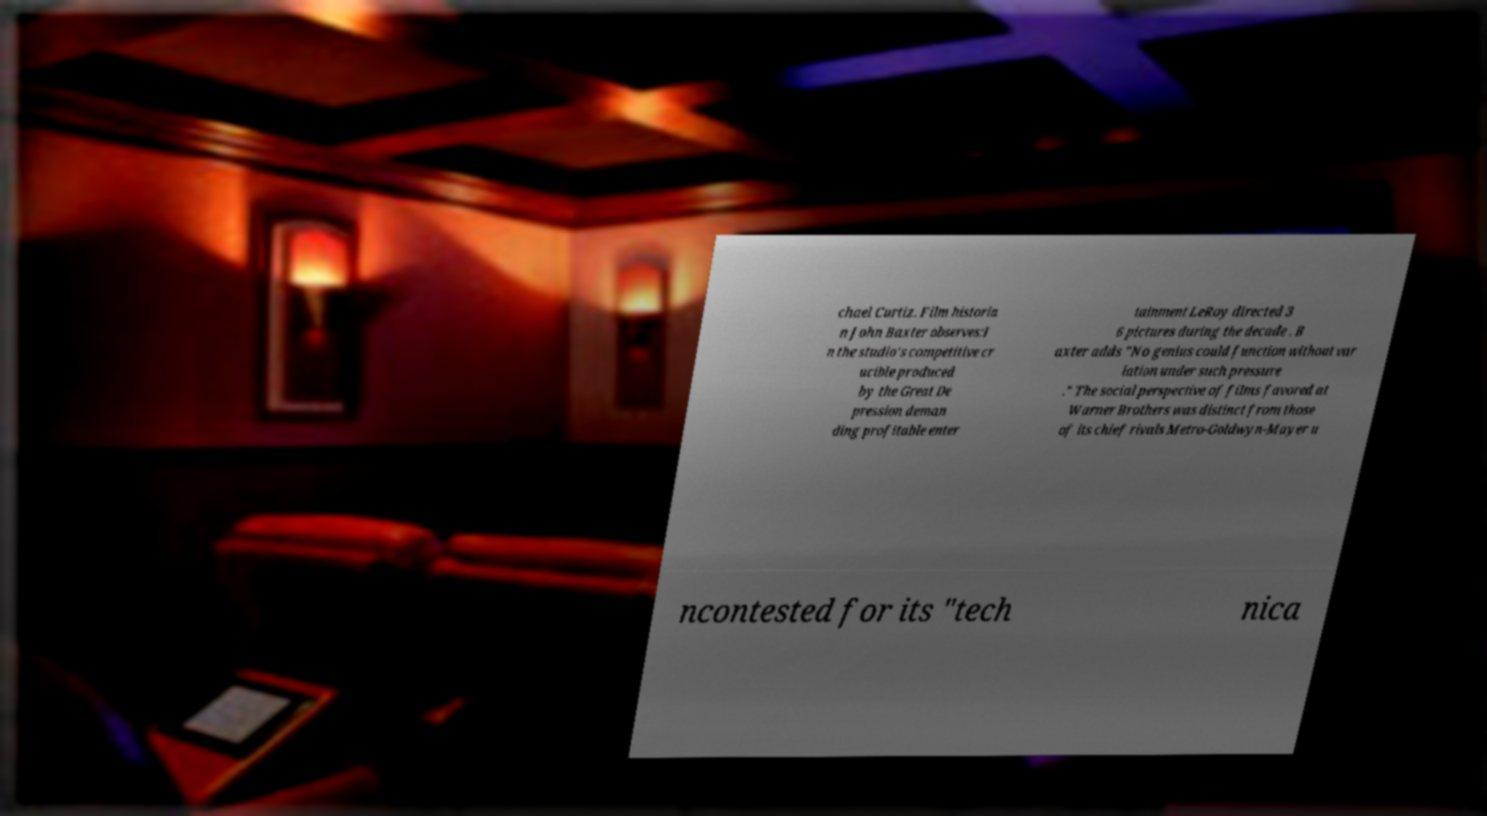Could you extract and type out the text from this image? chael Curtiz. Film historia n John Baxter observes:I n the studio's competitive cr ucible produced by the Great De pression deman ding profitable enter tainment LeRoy directed 3 6 pictures during the decade . B axter adds "No genius could function without var iation under such pressure ." The social perspective of films favored at Warner Brothers was distinct from those of its chief rivals Metro-Goldwyn-Mayer u ncontested for its "tech nica 